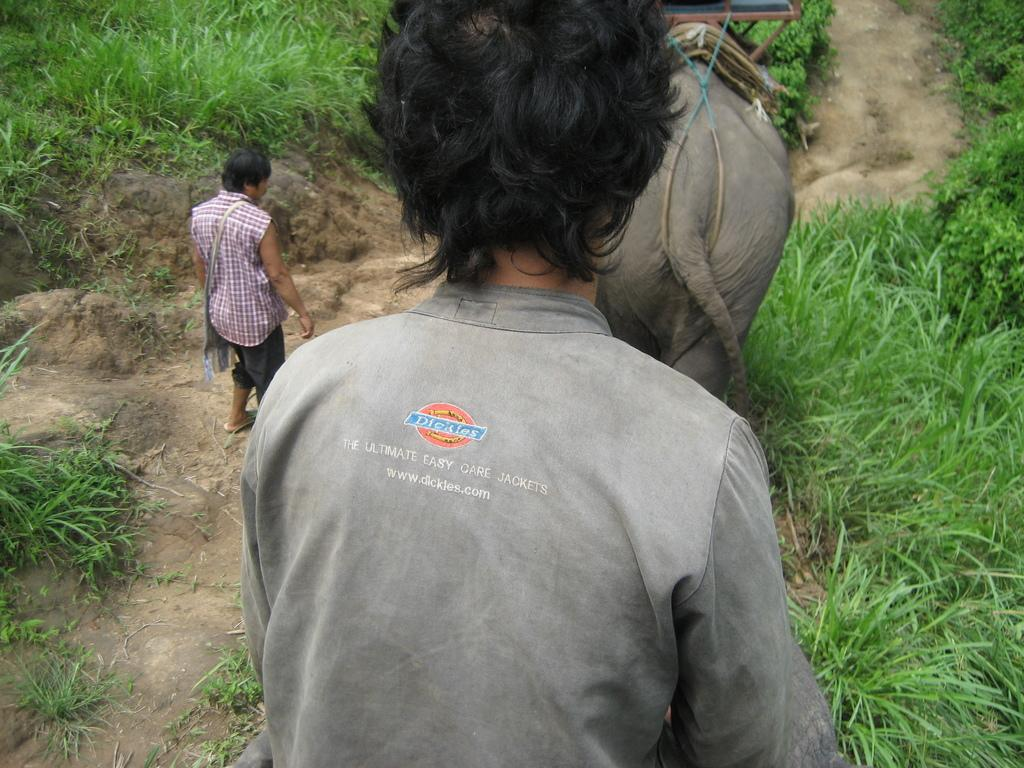Who is in the image with the elephant? There is a person in the image with the elephant, and another person is beside the elephant. What is the position of the elephant in relation to the first person? The elephant is in front of the first person. What type of vegetation is present in the image? Grass is present in the image. What type of selection process is being conducted in the image? There is no indication of a selection process in the image; it features a person, an elephant, and another person in a grassy area. Is it raining in the image? There is no indication of rain in the image; the sky or weather conditions are not mentioned. 